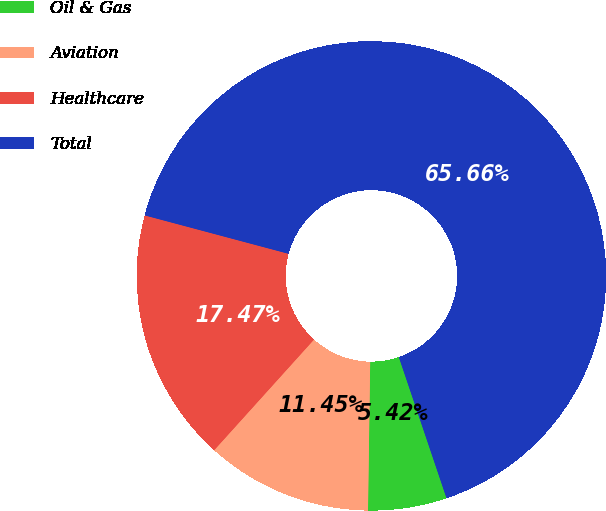Convert chart. <chart><loc_0><loc_0><loc_500><loc_500><pie_chart><fcel>Oil & Gas<fcel>Aviation<fcel>Healthcare<fcel>Total<nl><fcel>5.42%<fcel>11.45%<fcel>17.47%<fcel>65.66%<nl></chart> 